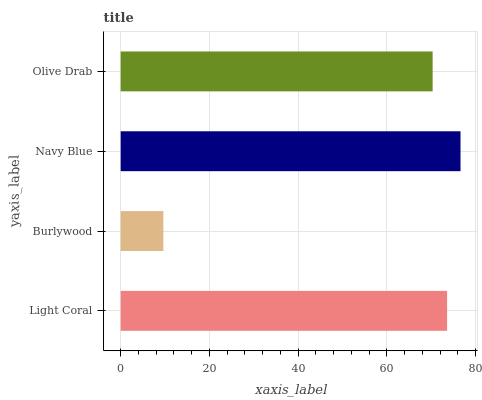Is Burlywood the minimum?
Answer yes or no. Yes. Is Navy Blue the maximum?
Answer yes or no. Yes. Is Navy Blue the minimum?
Answer yes or no. No. Is Burlywood the maximum?
Answer yes or no. No. Is Navy Blue greater than Burlywood?
Answer yes or no. Yes. Is Burlywood less than Navy Blue?
Answer yes or no. Yes. Is Burlywood greater than Navy Blue?
Answer yes or no. No. Is Navy Blue less than Burlywood?
Answer yes or no. No. Is Light Coral the high median?
Answer yes or no. Yes. Is Olive Drab the low median?
Answer yes or no. Yes. Is Burlywood the high median?
Answer yes or no. No. Is Navy Blue the low median?
Answer yes or no. No. 